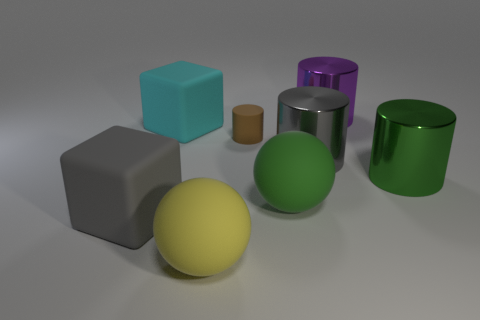Which objects appear to have a matte surface and which have a metallic one? In the image, the large grey cube, the smaller brown cylinder, the large green sphere, and the large yellow sphere all have matte surfaces. The large purple cylinder and the large green cylinder appear to have metallic surfaces. Are metallic surfaces more reflective than the matte ones in this image? Yes, the metallic surfaces on the purple and green cylinders are more reflective. You can observe this by noting the light highlights and reflections on their surfaces, which are not present on the matte objects. 